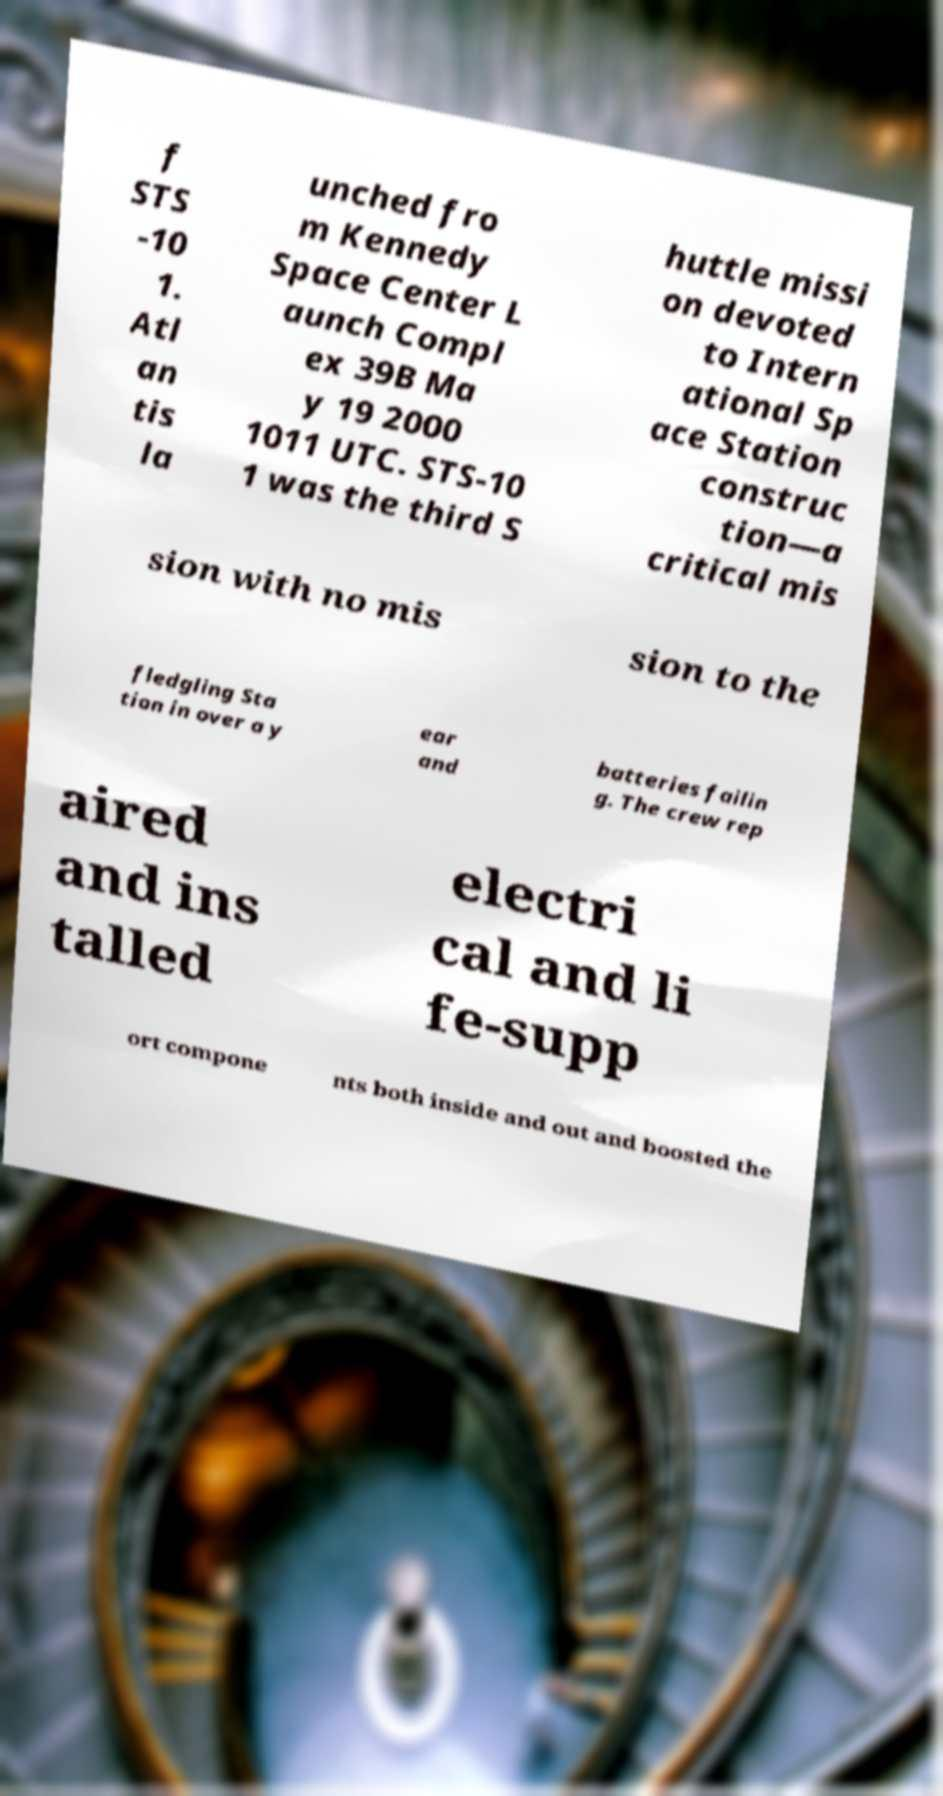There's text embedded in this image that I need extracted. Can you transcribe it verbatim? f STS -10 1. Atl an tis la unched fro m Kennedy Space Center L aunch Compl ex 39B Ma y 19 2000 1011 UTC. STS-10 1 was the third S huttle missi on devoted to Intern ational Sp ace Station construc tion—a critical mis sion with no mis sion to the fledgling Sta tion in over a y ear and batteries failin g. The crew rep aired and ins talled electri cal and li fe-supp ort compone nts both inside and out and boosted the 